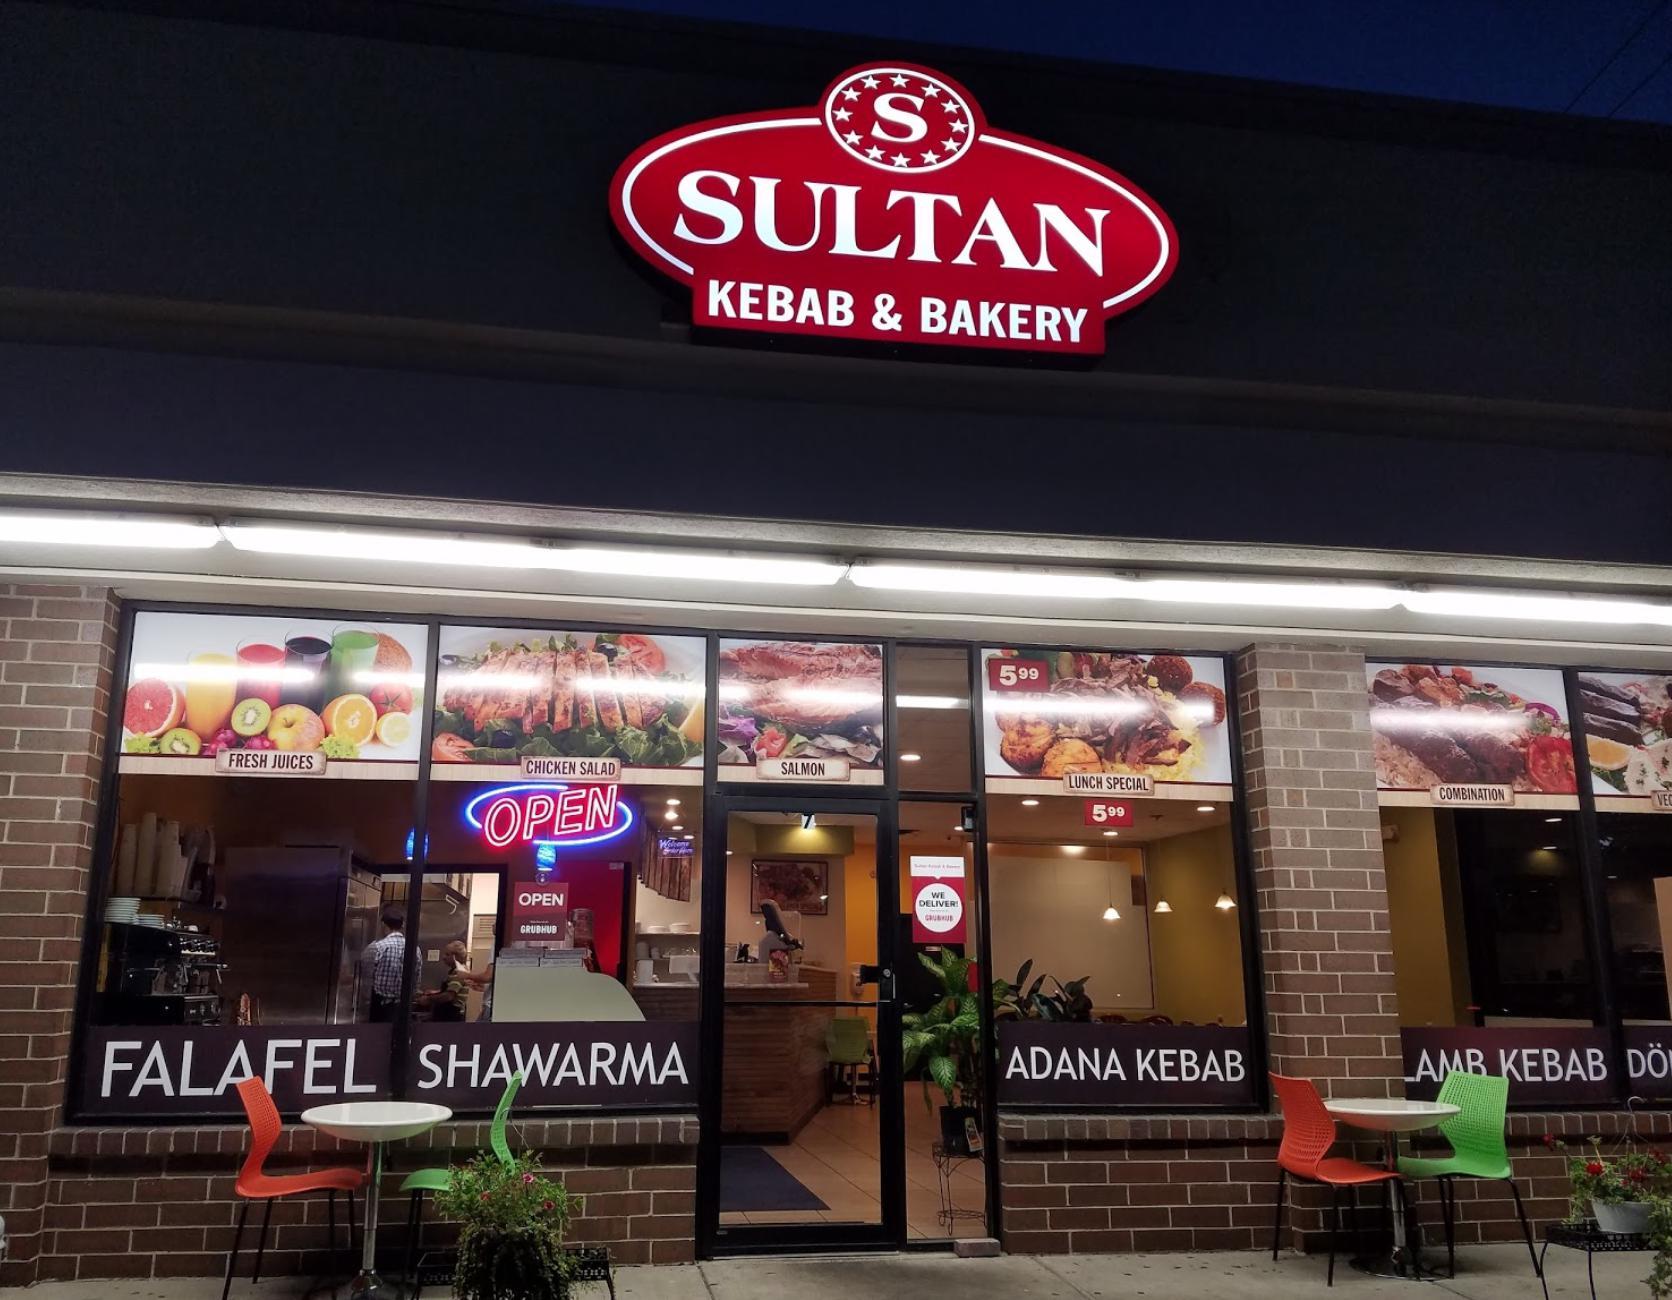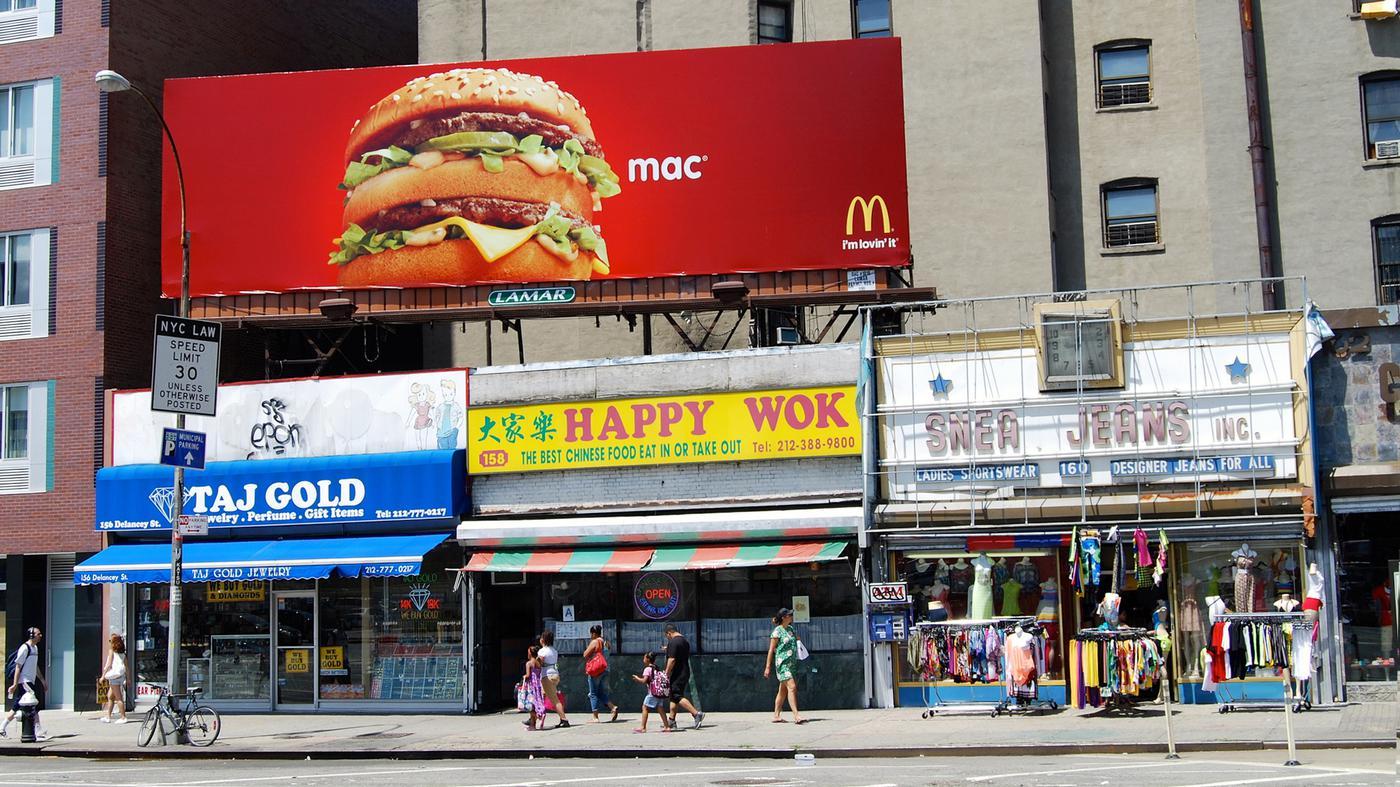The first image is the image on the left, the second image is the image on the right. Examine the images to the left and right. Is the description "One of the restaurants serves pizza." accurate? Answer yes or no. No. The first image is the image on the left, the second image is the image on the right. For the images shown, is this caption "There are tables under the awning in one image." true? Answer yes or no. No. 